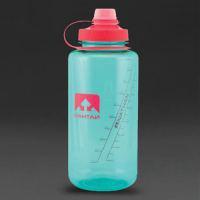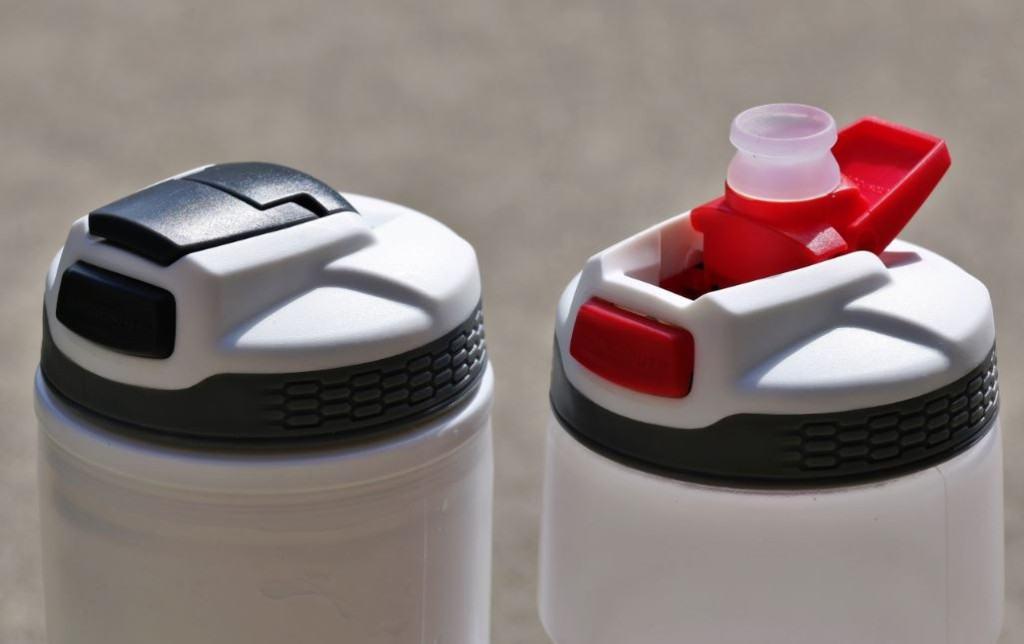The first image is the image on the left, the second image is the image on the right. Given the left and right images, does the statement "There are three water bottles in total." hold true? Answer yes or no. Yes. The first image is the image on the left, the second image is the image on the right. Analyze the images presented: Is the assertion "Two bottles are closed." valid? Answer yes or no. Yes. 